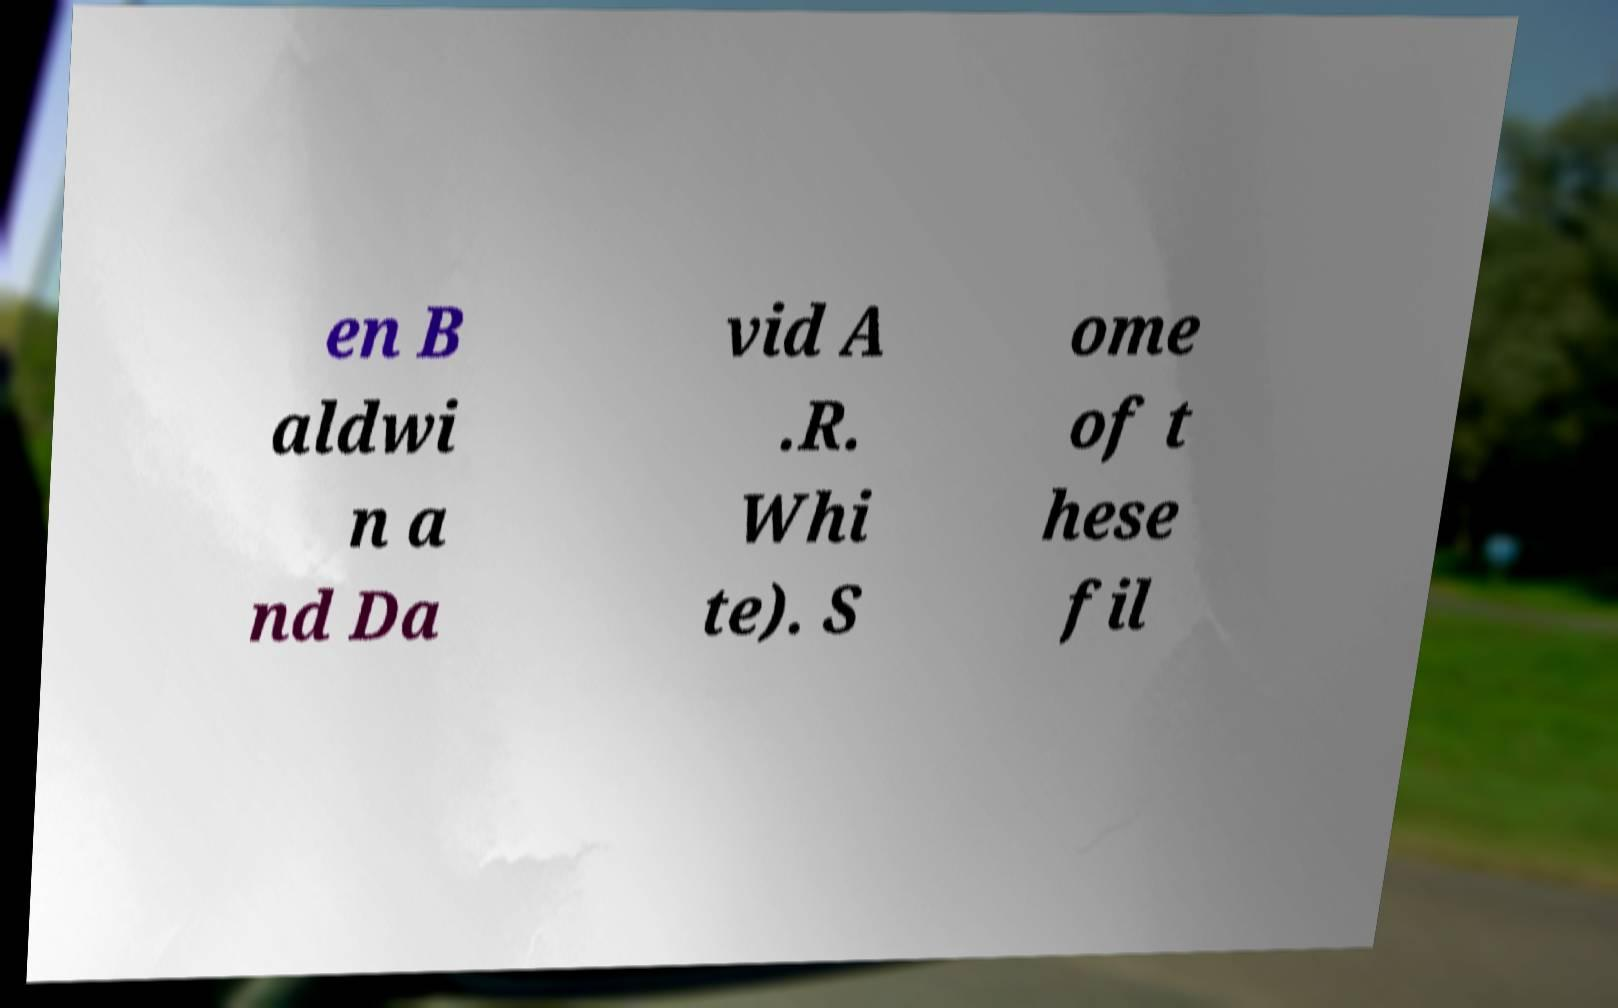What messages or text are displayed in this image? I need them in a readable, typed format. en B aldwi n a nd Da vid A .R. Whi te). S ome of t hese fil 